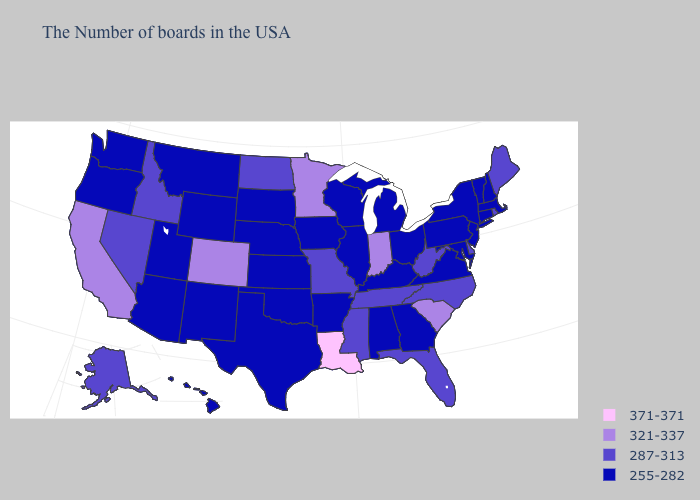Name the states that have a value in the range 287-313?
Concise answer only. Maine, Rhode Island, Delaware, North Carolina, West Virginia, Florida, Tennessee, Mississippi, Missouri, North Dakota, Idaho, Nevada, Alaska. Does Illinois have the lowest value in the USA?
Short answer required. Yes. Name the states that have a value in the range 321-337?
Be succinct. South Carolina, Indiana, Minnesota, Colorado, California. Does Louisiana have the highest value in the USA?
Answer briefly. Yes. Is the legend a continuous bar?
Be succinct. No. Does Nebraska have the same value as Illinois?
Be succinct. Yes. What is the highest value in the USA?
Answer briefly. 371-371. Which states have the lowest value in the MidWest?
Answer briefly. Ohio, Michigan, Wisconsin, Illinois, Iowa, Kansas, Nebraska, South Dakota. Does Rhode Island have the lowest value in the Northeast?
Short answer required. No. Name the states that have a value in the range 255-282?
Give a very brief answer. Massachusetts, New Hampshire, Vermont, Connecticut, New York, New Jersey, Maryland, Pennsylvania, Virginia, Ohio, Georgia, Michigan, Kentucky, Alabama, Wisconsin, Illinois, Arkansas, Iowa, Kansas, Nebraska, Oklahoma, Texas, South Dakota, Wyoming, New Mexico, Utah, Montana, Arizona, Washington, Oregon, Hawaii. Name the states that have a value in the range 255-282?
Keep it brief. Massachusetts, New Hampshire, Vermont, Connecticut, New York, New Jersey, Maryland, Pennsylvania, Virginia, Ohio, Georgia, Michigan, Kentucky, Alabama, Wisconsin, Illinois, Arkansas, Iowa, Kansas, Nebraska, Oklahoma, Texas, South Dakota, Wyoming, New Mexico, Utah, Montana, Arizona, Washington, Oregon, Hawaii. Does Louisiana have the highest value in the USA?
Keep it brief. Yes. Does the map have missing data?
Concise answer only. No. Which states have the highest value in the USA?
Concise answer only. Louisiana. What is the highest value in the USA?
Answer briefly. 371-371. 